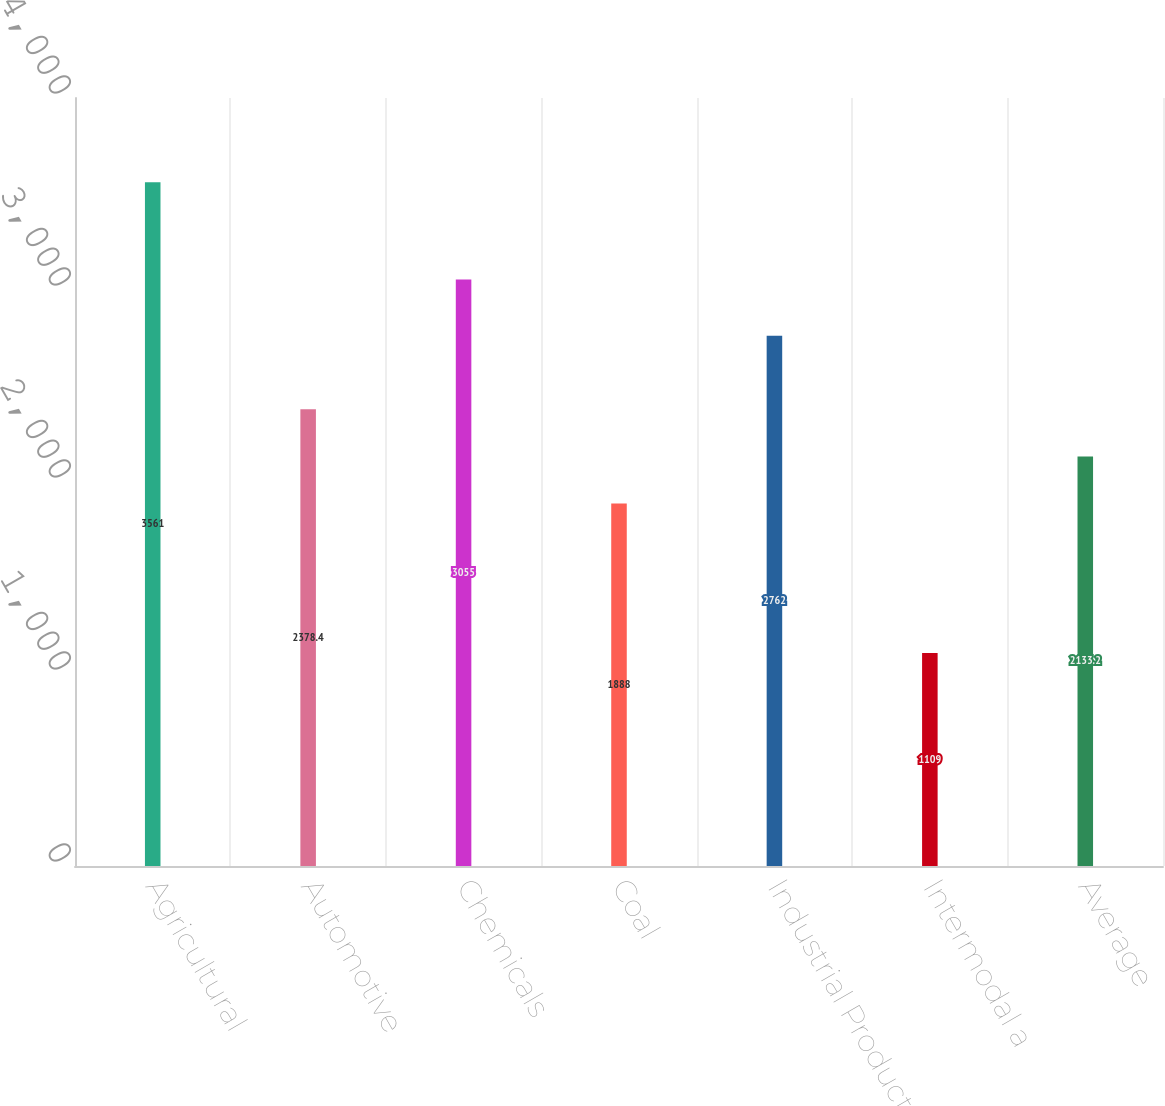Convert chart to OTSL. <chart><loc_0><loc_0><loc_500><loc_500><bar_chart><fcel>Agricultural<fcel>Automotive<fcel>Chemicals<fcel>Coal<fcel>Industrial Products<fcel>Intermodal a<fcel>Average<nl><fcel>3561<fcel>2378.4<fcel>3055<fcel>1888<fcel>2762<fcel>1109<fcel>2133.2<nl></chart> 